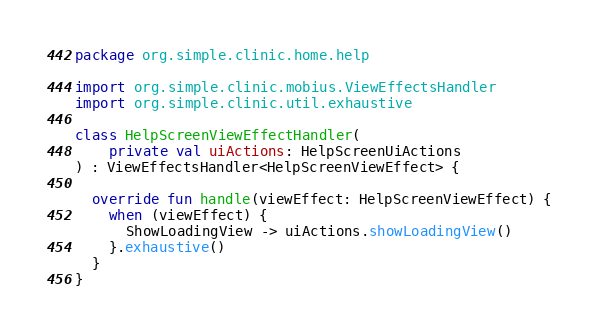Convert code to text. <code><loc_0><loc_0><loc_500><loc_500><_Kotlin_>package org.simple.clinic.home.help

import org.simple.clinic.mobius.ViewEffectsHandler
import org.simple.clinic.util.exhaustive

class HelpScreenViewEffectHandler(
    private val uiActions: HelpScreenUiActions
) : ViewEffectsHandler<HelpScreenViewEffect> {

  override fun handle(viewEffect: HelpScreenViewEffect) {
    when (viewEffect) {
      ShowLoadingView -> uiActions.showLoadingView()
    }.exhaustive()
  }
}
</code> 